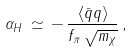<formula> <loc_0><loc_0><loc_500><loc_500>\alpha _ { H } \, \simeq \, - \, \frac { \langle \bar { q } q \rangle } { f _ { \pi } \, \sqrt { m _ { \chi } } } \, ,</formula> 